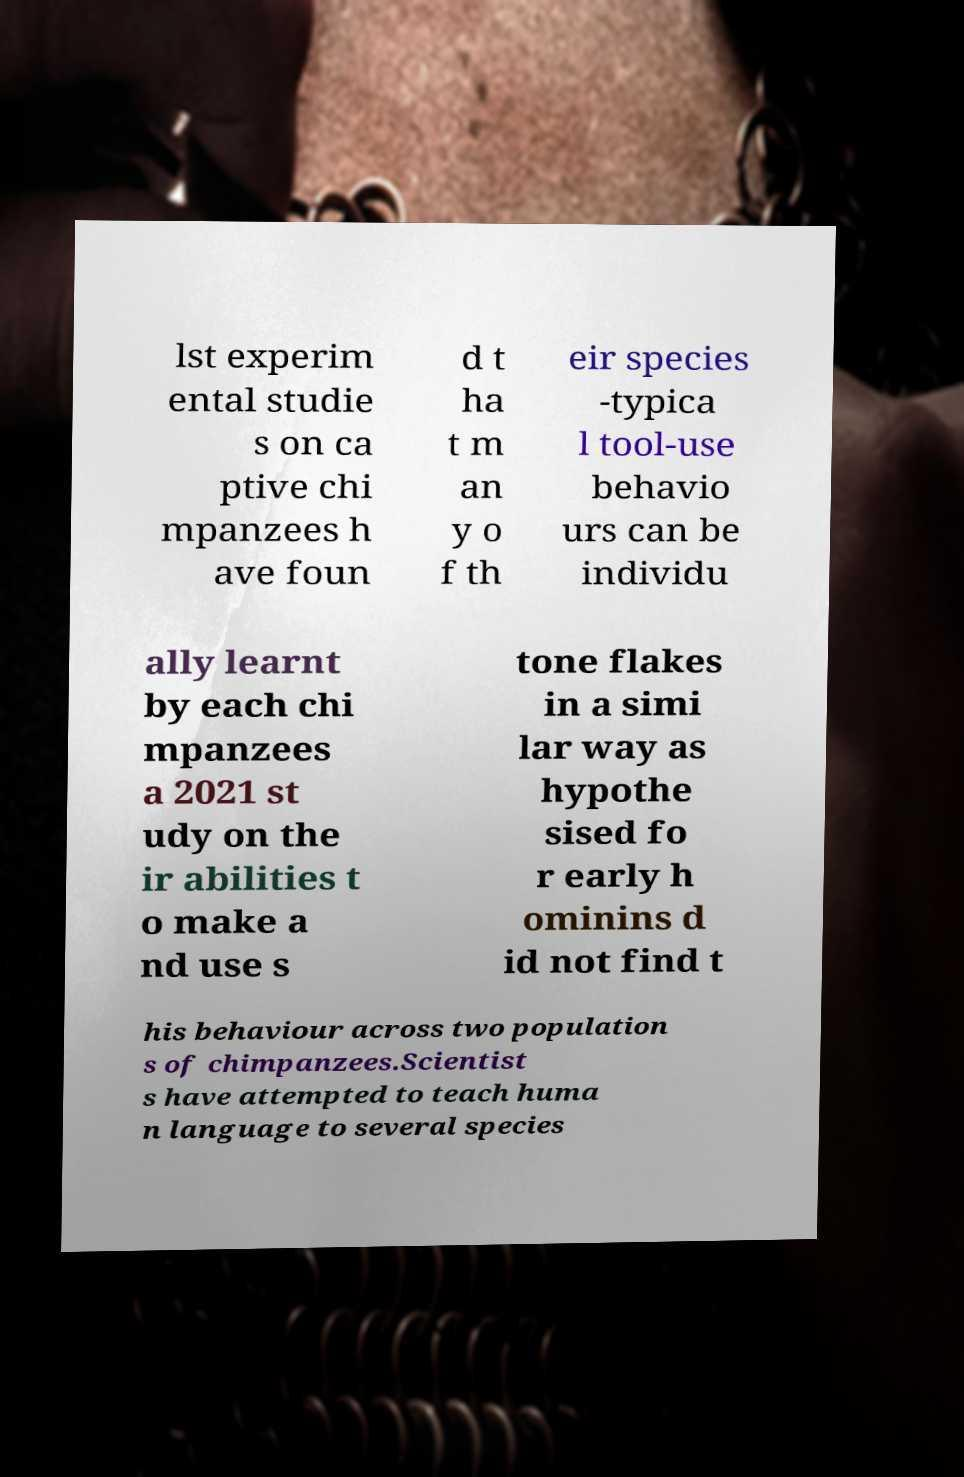Can you accurately transcribe the text from the provided image for me? lst experim ental studie s on ca ptive chi mpanzees h ave foun d t ha t m an y o f th eir species -typica l tool-use behavio urs can be individu ally learnt by each chi mpanzees a 2021 st udy on the ir abilities t o make a nd use s tone flakes in a simi lar way as hypothe sised fo r early h ominins d id not find t his behaviour across two population s of chimpanzees.Scientist s have attempted to teach huma n language to several species 